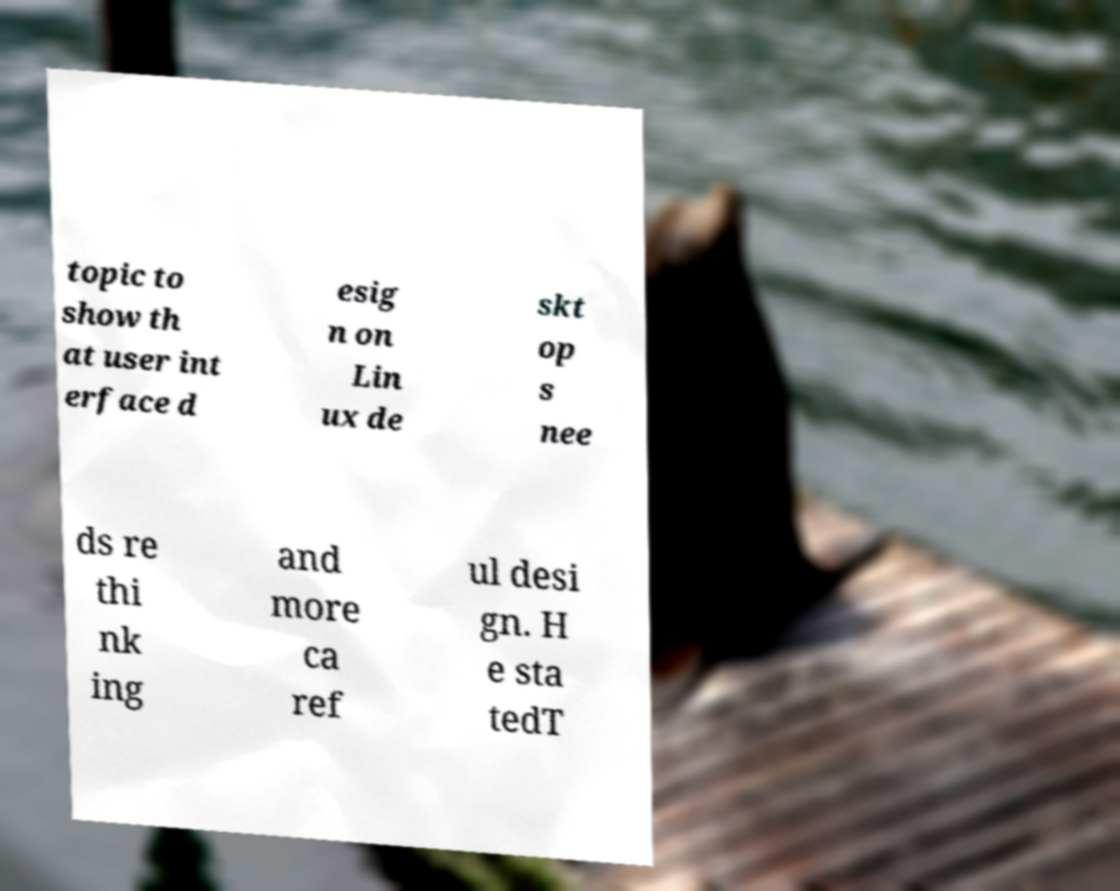There's text embedded in this image that I need extracted. Can you transcribe it verbatim? topic to show th at user int erface d esig n on Lin ux de skt op s nee ds re thi nk ing and more ca ref ul desi gn. H e sta tedT 